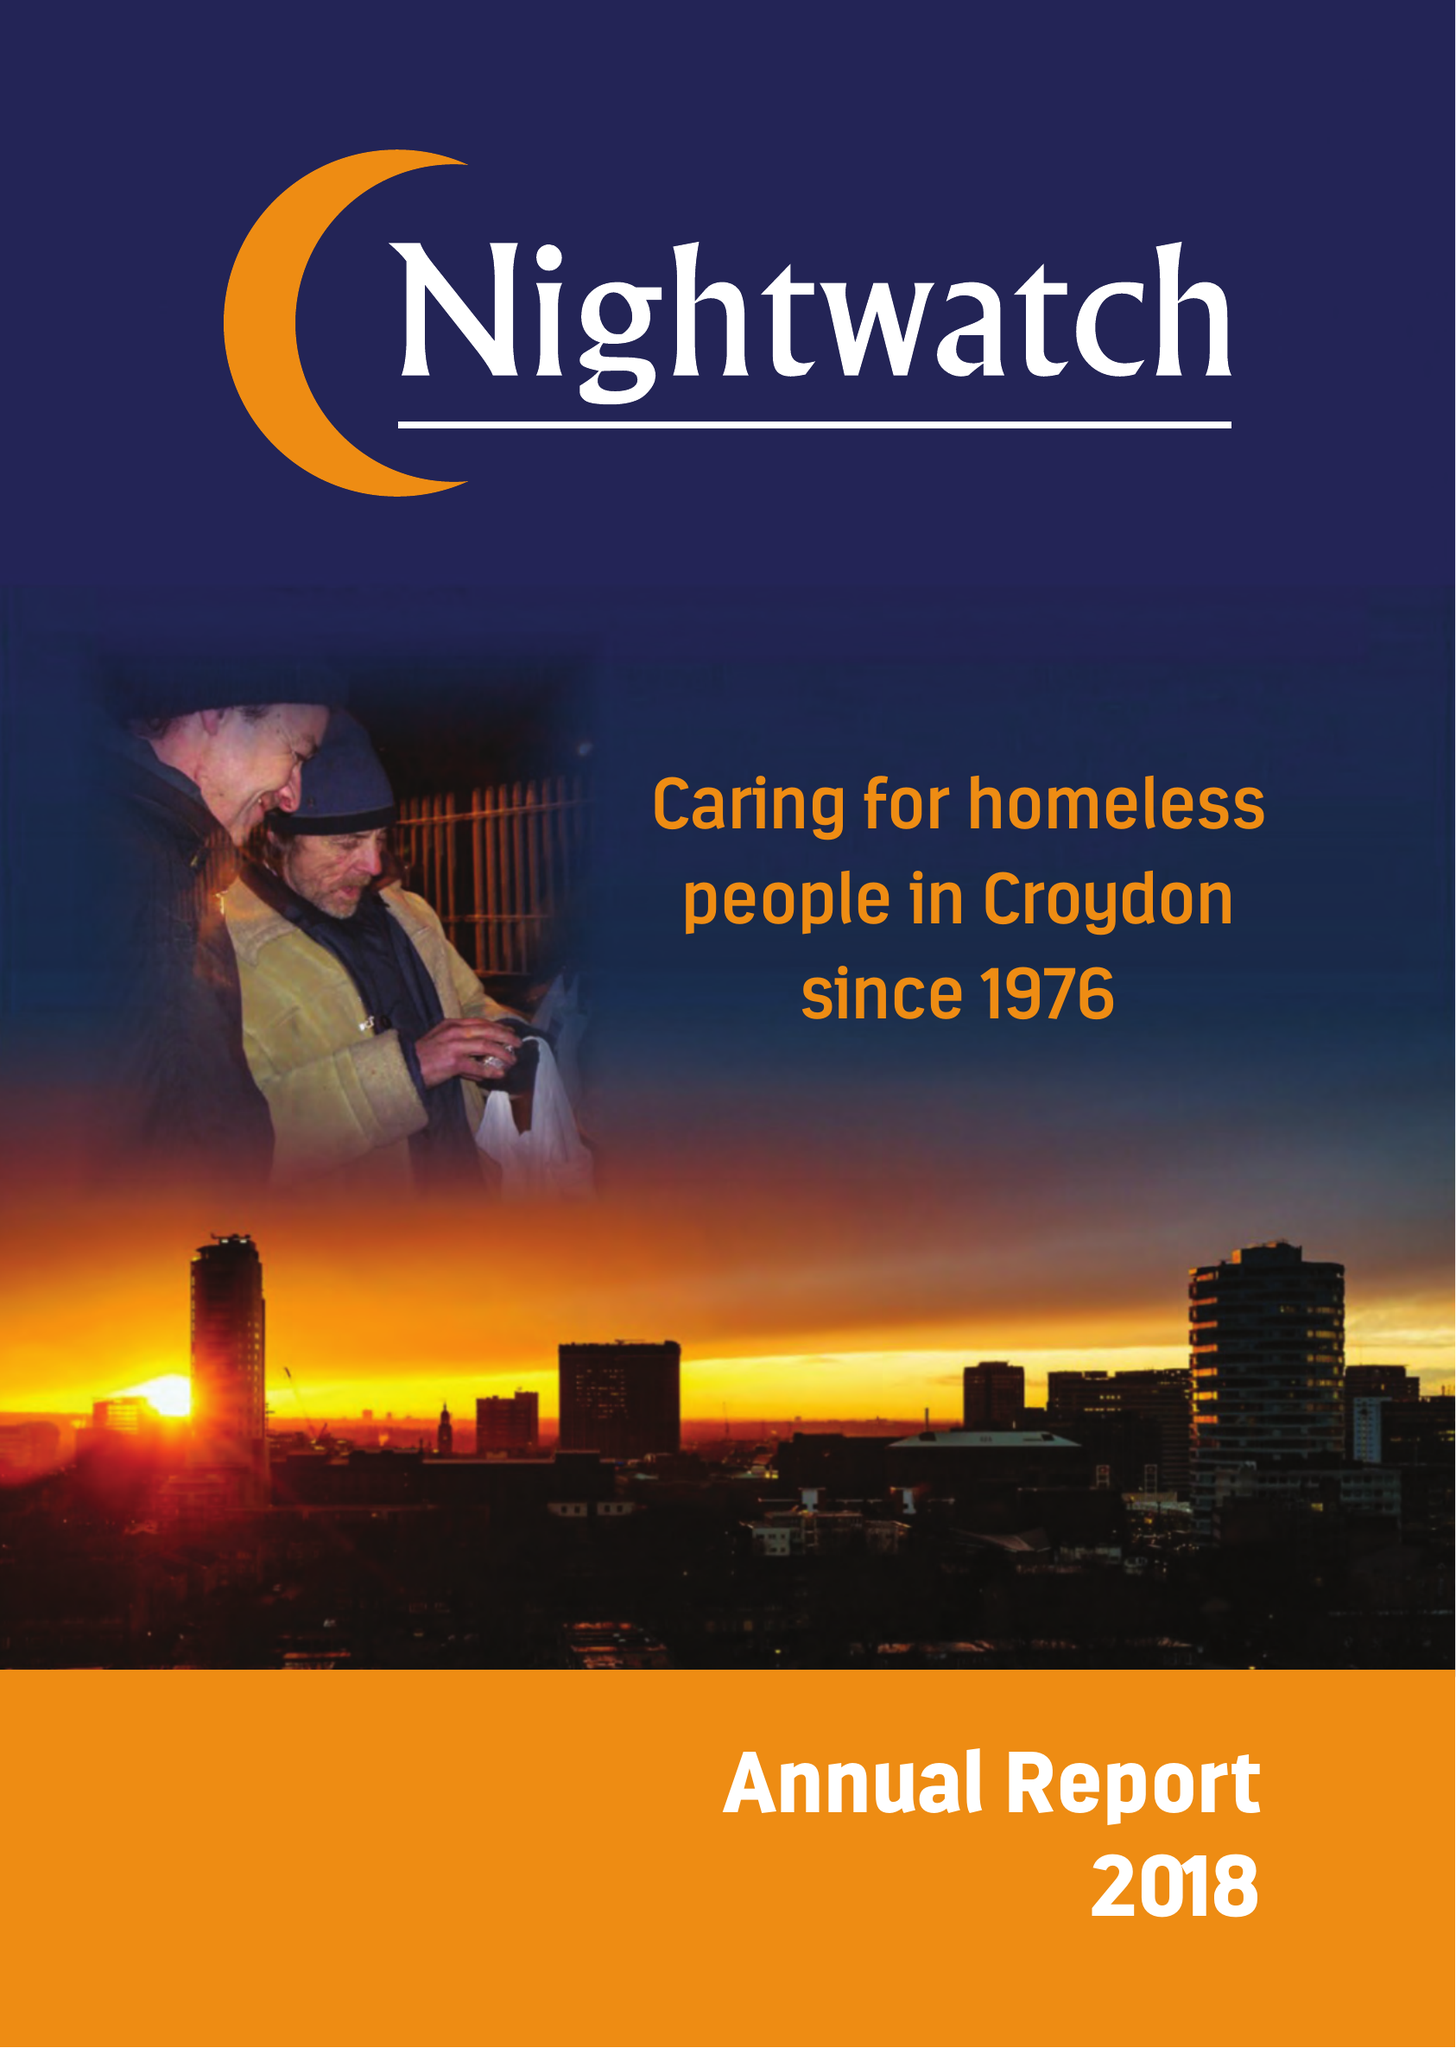What is the value for the income_annually_in_british_pounds?
Answer the question using a single word or phrase. 73968.00 